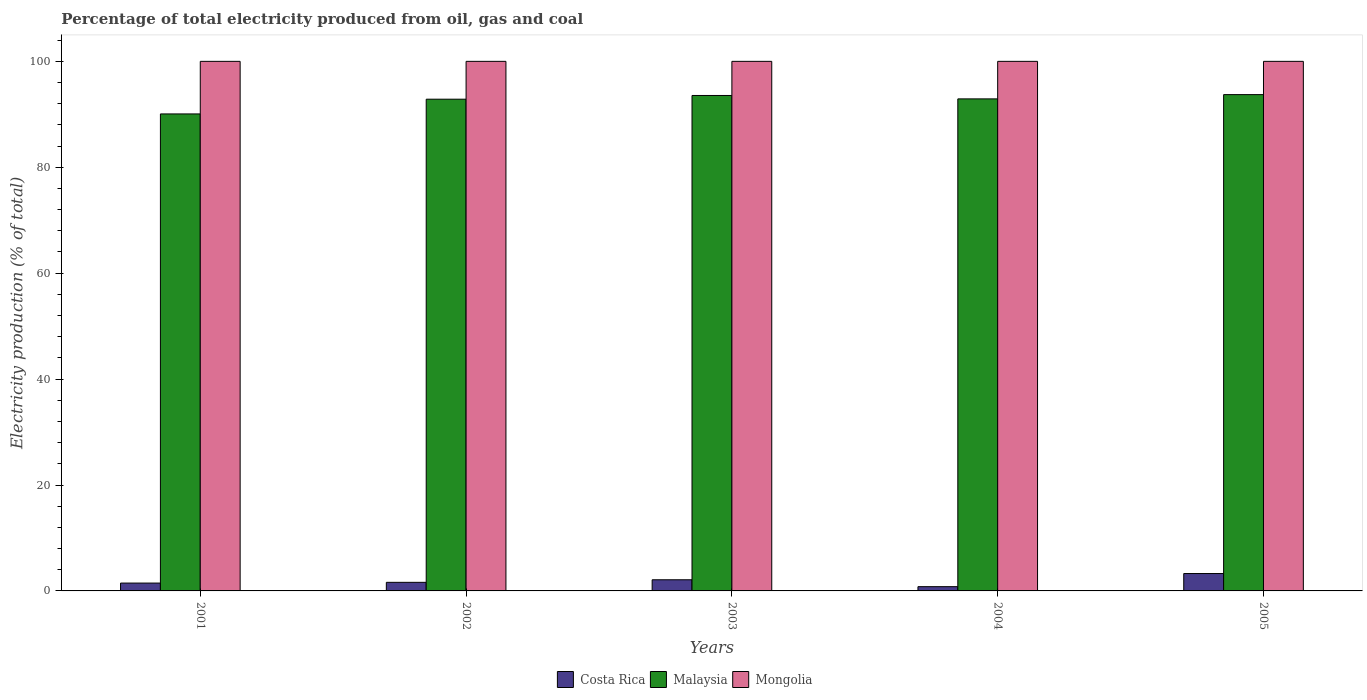How many different coloured bars are there?
Keep it short and to the point. 3. How many groups of bars are there?
Your response must be concise. 5. Are the number of bars per tick equal to the number of legend labels?
Make the answer very short. Yes. How many bars are there on the 4th tick from the left?
Give a very brief answer. 3. Across all years, what is the maximum electricity production in in Costa Rica?
Keep it short and to the point. 3.28. Across all years, what is the minimum electricity production in in Malaysia?
Offer a very short reply. 90.07. In which year was the electricity production in in Mongolia maximum?
Your answer should be very brief. 2001. In which year was the electricity production in in Costa Rica minimum?
Your answer should be very brief. 2004. What is the total electricity production in in Mongolia in the graph?
Provide a short and direct response. 500. What is the difference between the electricity production in in Costa Rica in 2002 and that in 2004?
Offer a terse response. 0.82. What is the difference between the electricity production in in Mongolia in 2003 and the electricity production in in Malaysia in 2001?
Offer a very short reply. 9.93. What is the average electricity production in in Mongolia per year?
Make the answer very short. 100. In the year 2003, what is the difference between the electricity production in in Costa Rica and electricity production in in Mongolia?
Keep it short and to the point. -97.89. What is the ratio of the electricity production in in Costa Rica in 2004 to that in 2005?
Keep it short and to the point. 0.24. Is the difference between the electricity production in in Costa Rica in 2003 and 2005 greater than the difference between the electricity production in in Mongolia in 2003 and 2005?
Give a very brief answer. No. What is the difference between the highest and the second highest electricity production in in Costa Rica?
Ensure brevity in your answer.  1.17. What is the difference between the highest and the lowest electricity production in in Malaysia?
Your response must be concise. 3.65. In how many years, is the electricity production in in Malaysia greater than the average electricity production in in Malaysia taken over all years?
Your answer should be very brief. 4. Is the sum of the electricity production in in Malaysia in 2002 and 2003 greater than the maximum electricity production in in Costa Rica across all years?
Offer a terse response. Yes. What does the 2nd bar from the left in 2005 represents?
Your answer should be very brief. Malaysia. What does the 3rd bar from the right in 2002 represents?
Your answer should be very brief. Costa Rica. How many bars are there?
Keep it short and to the point. 15. Are all the bars in the graph horizontal?
Offer a terse response. No. Are the values on the major ticks of Y-axis written in scientific E-notation?
Make the answer very short. No. How many legend labels are there?
Your response must be concise. 3. How are the legend labels stacked?
Offer a very short reply. Horizontal. What is the title of the graph?
Keep it short and to the point. Percentage of total electricity produced from oil, gas and coal. What is the label or title of the X-axis?
Provide a short and direct response. Years. What is the label or title of the Y-axis?
Offer a very short reply. Electricity production (% of total). What is the Electricity production (% of total) in Costa Rica in 2001?
Give a very brief answer. 1.48. What is the Electricity production (% of total) of Malaysia in 2001?
Your response must be concise. 90.07. What is the Electricity production (% of total) in Mongolia in 2001?
Provide a short and direct response. 100. What is the Electricity production (% of total) in Costa Rica in 2002?
Your answer should be very brief. 1.62. What is the Electricity production (% of total) of Malaysia in 2002?
Make the answer very short. 92.86. What is the Electricity production (% of total) of Costa Rica in 2003?
Keep it short and to the point. 2.11. What is the Electricity production (% of total) of Malaysia in 2003?
Make the answer very short. 93.56. What is the Electricity production (% of total) of Mongolia in 2003?
Make the answer very short. 100. What is the Electricity production (% of total) of Costa Rica in 2004?
Your response must be concise. 0.8. What is the Electricity production (% of total) in Malaysia in 2004?
Provide a succinct answer. 92.91. What is the Electricity production (% of total) of Costa Rica in 2005?
Provide a short and direct response. 3.28. What is the Electricity production (% of total) of Malaysia in 2005?
Give a very brief answer. 93.72. Across all years, what is the maximum Electricity production (% of total) of Costa Rica?
Your answer should be very brief. 3.28. Across all years, what is the maximum Electricity production (% of total) of Malaysia?
Your answer should be very brief. 93.72. Across all years, what is the maximum Electricity production (% of total) in Mongolia?
Your response must be concise. 100. Across all years, what is the minimum Electricity production (% of total) of Costa Rica?
Provide a succinct answer. 0.8. Across all years, what is the minimum Electricity production (% of total) of Malaysia?
Offer a terse response. 90.07. What is the total Electricity production (% of total) in Costa Rica in the graph?
Your answer should be very brief. 9.29. What is the total Electricity production (% of total) of Malaysia in the graph?
Provide a succinct answer. 463.12. What is the difference between the Electricity production (% of total) in Costa Rica in 2001 and that in 2002?
Make the answer very short. -0.14. What is the difference between the Electricity production (% of total) in Malaysia in 2001 and that in 2002?
Provide a short and direct response. -2.78. What is the difference between the Electricity production (% of total) of Costa Rica in 2001 and that in 2003?
Your answer should be compact. -0.62. What is the difference between the Electricity production (% of total) of Malaysia in 2001 and that in 2003?
Your response must be concise. -3.49. What is the difference between the Electricity production (% of total) in Mongolia in 2001 and that in 2003?
Ensure brevity in your answer.  0. What is the difference between the Electricity production (% of total) of Costa Rica in 2001 and that in 2004?
Your response must be concise. 0.68. What is the difference between the Electricity production (% of total) of Malaysia in 2001 and that in 2004?
Provide a succinct answer. -2.84. What is the difference between the Electricity production (% of total) of Costa Rica in 2001 and that in 2005?
Make the answer very short. -1.8. What is the difference between the Electricity production (% of total) of Malaysia in 2001 and that in 2005?
Make the answer very short. -3.65. What is the difference between the Electricity production (% of total) of Costa Rica in 2002 and that in 2003?
Offer a very short reply. -0.49. What is the difference between the Electricity production (% of total) in Malaysia in 2002 and that in 2003?
Offer a very short reply. -0.7. What is the difference between the Electricity production (% of total) in Costa Rica in 2002 and that in 2004?
Your answer should be compact. 0.82. What is the difference between the Electricity production (% of total) in Malaysia in 2002 and that in 2004?
Your response must be concise. -0.06. What is the difference between the Electricity production (% of total) of Costa Rica in 2002 and that in 2005?
Your answer should be very brief. -1.66. What is the difference between the Electricity production (% of total) of Malaysia in 2002 and that in 2005?
Your response must be concise. -0.86. What is the difference between the Electricity production (% of total) of Mongolia in 2002 and that in 2005?
Your answer should be compact. 0. What is the difference between the Electricity production (% of total) of Costa Rica in 2003 and that in 2004?
Provide a short and direct response. 1.3. What is the difference between the Electricity production (% of total) in Malaysia in 2003 and that in 2004?
Ensure brevity in your answer.  0.64. What is the difference between the Electricity production (% of total) of Mongolia in 2003 and that in 2004?
Offer a very short reply. 0. What is the difference between the Electricity production (% of total) of Costa Rica in 2003 and that in 2005?
Give a very brief answer. -1.17. What is the difference between the Electricity production (% of total) in Malaysia in 2003 and that in 2005?
Make the answer very short. -0.16. What is the difference between the Electricity production (% of total) in Mongolia in 2003 and that in 2005?
Provide a succinct answer. 0. What is the difference between the Electricity production (% of total) of Costa Rica in 2004 and that in 2005?
Ensure brevity in your answer.  -2.48. What is the difference between the Electricity production (% of total) of Malaysia in 2004 and that in 2005?
Your answer should be very brief. -0.81. What is the difference between the Electricity production (% of total) of Costa Rica in 2001 and the Electricity production (% of total) of Malaysia in 2002?
Ensure brevity in your answer.  -91.37. What is the difference between the Electricity production (% of total) of Costa Rica in 2001 and the Electricity production (% of total) of Mongolia in 2002?
Provide a short and direct response. -98.52. What is the difference between the Electricity production (% of total) of Malaysia in 2001 and the Electricity production (% of total) of Mongolia in 2002?
Offer a very short reply. -9.93. What is the difference between the Electricity production (% of total) in Costa Rica in 2001 and the Electricity production (% of total) in Malaysia in 2003?
Provide a short and direct response. -92.07. What is the difference between the Electricity production (% of total) of Costa Rica in 2001 and the Electricity production (% of total) of Mongolia in 2003?
Provide a succinct answer. -98.52. What is the difference between the Electricity production (% of total) in Malaysia in 2001 and the Electricity production (% of total) in Mongolia in 2003?
Give a very brief answer. -9.93. What is the difference between the Electricity production (% of total) of Costa Rica in 2001 and the Electricity production (% of total) of Malaysia in 2004?
Make the answer very short. -91.43. What is the difference between the Electricity production (% of total) of Costa Rica in 2001 and the Electricity production (% of total) of Mongolia in 2004?
Your response must be concise. -98.52. What is the difference between the Electricity production (% of total) in Malaysia in 2001 and the Electricity production (% of total) in Mongolia in 2004?
Provide a succinct answer. -9.93. What is the difference between the Electricity production (% of total) of Costa Rica in 2001 and the Electricity production (% of total) of Malaysia in 2005?
Provide a succinct answer. -92.24. What is the difference between the Electricity production (% of total) in Costa Rica in 2001 and the Electricity production (% of total) in Mongolia in 2005?
Your answer should be compact. -98.52. What is the difference between the Electricity production (% of total) in Malaysia in 2001 and the Electricity production (% of total) in Mongolia in 2005?
Offer a very short reply. -9.93. What is the difference between the Electricity production (% of total) of Costa Rica in 2002 and the Electricity production (% of total) of Malaysia in 2003?
Your response must be concise. -91.94. What is the difference between the Electricity production (% of total) of Costa Rica in 2002 and the Electricity production (% of total) of Mongolia in 2003?
Your answer should be very brief. -98.38. What is the difference between the Electricity production (% of total) of Malaysia in 2002 and the Electricity production (% of total) of Mongolia in 2003?
Your response must be concise. -7.14. What is the difference between the Electricity production (% of total) in Costa Rica in 2002 and the Electricity production (% of total) in Malaysia in 2004?
Provide a succinct answer. -91.29. What is the difference between the Electricity production (% of total) of Costa Rica in 2002 and the Electricity production (% of total) of Mongolia in 2004?
Keep it short and to the point. -98.38. What is the difference between the Electricity production (% of total) of Malaysia in 2002 and the Electricity production (% of total) of Mongolia in 2004?
Keep it short and to the point. -7.14. What is the difference between the Electricity production (% of total) of Costa Rica in 2002 and the Electricity production (% of total) of Malaysia in 2005?
Your response must be concise. -92.1. What is the difference between the Electricity production (% of total) of Costa Rica in 2002 and the Electricity production (% of total) of Mongolia in 2005?
Provide a succinct answer. -98.38. What is the difference between the Electricity production (% of total) in Malaysia in 2002 and the Electricity production (% of total) in Mongolia in 2005?
Offer a terse response. -7.14. What is the difference between the Electricity production (% of total) of Costa Rica in 2003 and the Electricity production (% of total) of Malaysia in 2004?
Your response must be concise. -90.81. What is the difference between the Electricity production (% of total) in Costa Rica in 2003 and the Electricity production (% of total) in Mongolia in 2004?
Ensure brevity in your answer.  -97.89. What is the difference between the Electricity production (% of total) in Malaysia in 2003 and the Electricity production (% of total) in Mongolia in 2004?
Give a very brief answer. -6.44. What is the difference between the Electricity production (% of total) of Costa Rica in 2003 and the Electricity production (% of total) of Malaysia in 2005?
Your answer should be compact. -91.61. What is the difference between the Electricity production (% of total) in Costa Rica in 2003 and the Electricity production (% of total) in Mongolia in 2005?
Your response must be concise. -97.89. What is the difference between the Electricity production (% of total) in Malaysia in 2003 and the Electricity production (% of total) in Mongolia in 2005?
Keep it short and to the point. -6.44. What is the difference between the Electricity production (% of total) in Costa Rica in 2004 and the Electricity production (% of total) in Malaysia in 2005?
Your response must be concise. -92.92. What is the difference between the Electricity production (% of total) in Costa Rica in 2004 and the Electricity production (% of total) in Mongolia in 2005?
Ensure brevity in your answer.  -99.2. What is the difference between the Electricity production (% of total) in Malaysia in 2004 and the Electricity production (% of total) in Mongolia in 2005?
Make the answer very short. -7.09. What is the average Electricity production (% of total) of Costa Rica per year?
Ensure brevity in your answer.  1.86. What is the average Electricity production (% of total) of Malaysia per year?
Your answer should be very brief. 92.62. What is the average Electricity production (% of total) of Mongolia per year?
Make the answer very short. 100. In the year 2001, what is the difference between the Electricity production (% of total) of Costa Rica and Electricity production (% of total) of Malaysia?
Offer a terse response. -88.59. In the year 2001, what is the difference between the Electricity production (% of total) in Costa Rica and Electricity production (% of total) in Mongolia?
Offer a terse response. -98.52. In the year 2001, what is the difference between the Electricity production (% of total) in Malaysia and Electricity production (% of total) in Mongolia?
Your answer should be compact. -9.93. In the year 2002, what is the difference between the Electricity production (% of total) of Costa Rica and Electricity production (% of total) of Malaysia?
Your response must be concise. -91.23. In the year 2002, what is the difference between the Electricity production (% of total) of Costa Rica and Electricity production (% of total) of Mongolia?
Ensure brevity in your answer.  -98.38. In the year 2002, what is the difference between the Electricity production (% of total) in Malaysia and Electricity production (% of total) in Mongolia?
Offer a very short reply. -7.14. In the year 2003, what is the difference between the Electricity production (% of total) in Costa Rica and Electricity production (% of total) in Malaysia?
Your answer should be compact. -91.45. In the year 2003, what is the difference between the Electricity production (% of total) in Costa Rica and Electricity production (% of total) in Mongolia?
Ensure brevity in your answer.  -97.89. In the year 2003, what is the difference between the Electricity production (% of total) in Malaysia and Electricity production (% of total) in Mongolia?
Provide a short and direct response. -6.44. In the year 2004, what is the difference between the Electricity production (% of total) of Costa Rica and Electricity production (% of total) of Malaysia?
Ensure brevity in your answer.  -92.11. In the year 2004, what is the difference between the Electricity production (% of total) of Costa Rica and Electricity production (% of total) of Mongolia?
Your answer should be very brief. -99.2. In the year 2004, what is the difference between the Electricity production (% of total) of Malaysia and Electricity production (% of total) of Mongolia?
Provide a succinct answer. -7.09. In the year 2005, what is the difference between the Electricity production (% of total) in Costa Rica and Electricity production (% of total) in Malaysia?
Ensure brevity in your answer.  -90.44. In the year 2005, what is the difference between the Electricity production (% of total) of Costa Rica and Electricity production (% of total) of Mongolia?
Your answer should be very brief. -96.72. In the year 2005, what is the difference between the Electricity production (% of total) of Malaysia and Electricity production (% of total) of Mongolia?
Your answer should be very brief. -6.28. What is the ratio of the Electricity production (% of total) of Costa Rica in 2001 to that in 2002?
Your response must be concise. 0.91. What is the ratio of the Electricity production (% of total) of Costa Rica in 2001 to that in 2003?
Offer a terse response. 0.7. What is the ratio of the Electricity production (% of total) of Malaysia in 2001 to that in 2003?
Your answer should be compact. 0.96. What is the ratio of the Electricity production (% of total) in Mongolia in 2001 to that in 2003?
Your answer should be compact. 1. What is the ratio of the Electricity production (% of total) in Costa Rica in 2001 to that in 2004?
Your answer should be very brief. 1.85. What is the ratio of the Electricity production (% of total) in Malaysia in 2001 to that in 2004?
Your answer should be very brief. 0.97. What is the ratio of the Electricity production (% of total) in Mongolia in 2001 to that in 2004?
Ensure brevity in your answer.  1. What is the ratio of the Electricity production (% of total) in Costa Rica in 2001 to that in 2005?
Offer a very short reply. 0.45. What is the ratio of the Electricity production (% of total) in Malaysia in 2001 to that in 2005?
Make the answer very short. 0.96. What is the ratio of the Electricity production (% of total) of Costa Rica in 2002 to that in 2003?
Your answer should be very brief. 0.77. What is the ratio of the Electricity production (% of total) in Mongolia in 2002 to that in 2003?
Your response must be concise. 1. What is the ratio of the Electricity production (% of total) in Costa Rica in 2002 to that in 2004?
Your response must be concise. 2.02. What is the ratio of the Electricity production (% of total) in Malaysia in 2002 to that in 2004?
Give a very brief answer. 1. What is the ratio of the Electricity production (% of total) in Mongolia in 2002 to that in 2004?
Provide a short and direct response. 1. What is the ratio of the Electricity production (% of total) in Costa Rica in 2002 to that in 2005?
Provide a short and direct response. 0.49. What is the ratio of the Electricity production (% of total) in Malaysia in 2002 to that in 2005?
Keep it short and to the point. 0.99. What is the ratio of the Electricity production (% of total) of Mongolia in 2002 to that in 2005?
Offer a terse response. 1. What is the ratio of the Electricity production (% of total) of Costa Rica in 2003 to that in 2004?
Your answer should be very brief. 2.62. What is the ratio of the Electricity production (% of total) in Malaysia in 2003 to that in 2004?
Keep it short and to the point. 1.01. What is the ratio of the Electricity production (% of total) in Costa Rica in 2003 to that in 2005?
Provide a short and direct response. 0.64. What is the ratio of the Electricity production (% of total) of Costa Rica in 2004 to that in 2005?
Your answer should be compact. 0.24. What is the difference between the highest and the second highest Electricity production (% of total) of Costa Rica?
Keep it short and to the point. 1.17. What is the difference between the highest and the second highest Electricity production (% of total) of Malaysia?
Give a very brief answer. 0.16. What is the difference between the highest and the second highest Electricity production (% of total) in Mongolia?
Your response must be concise. 0. What is the difference between the highest and the lowest Electricity production (% of total) in Costa Rica?
Provide a succinct answer. 2.48. What is the difference between the highest and the lowest Electricity production (% of total) in Malaysia?
Offer a very short reply. 3.65. 